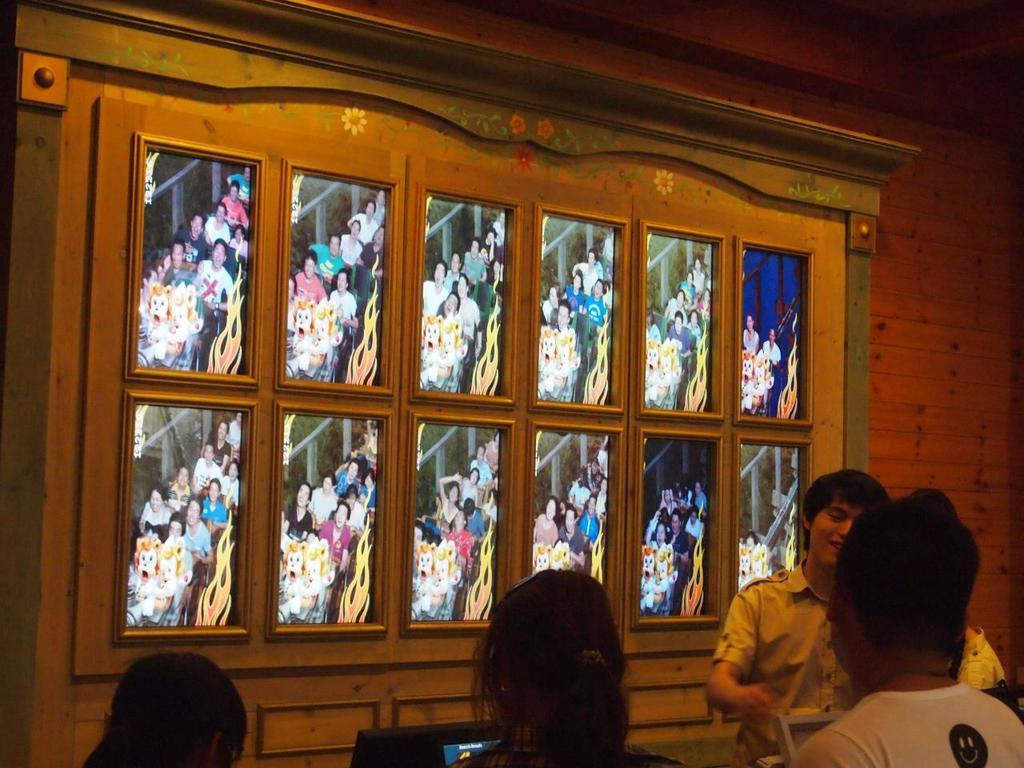Can you describe this image briefly? In this picture we can see some people where a man smiling and in the background we can see photo frames on the wall. 